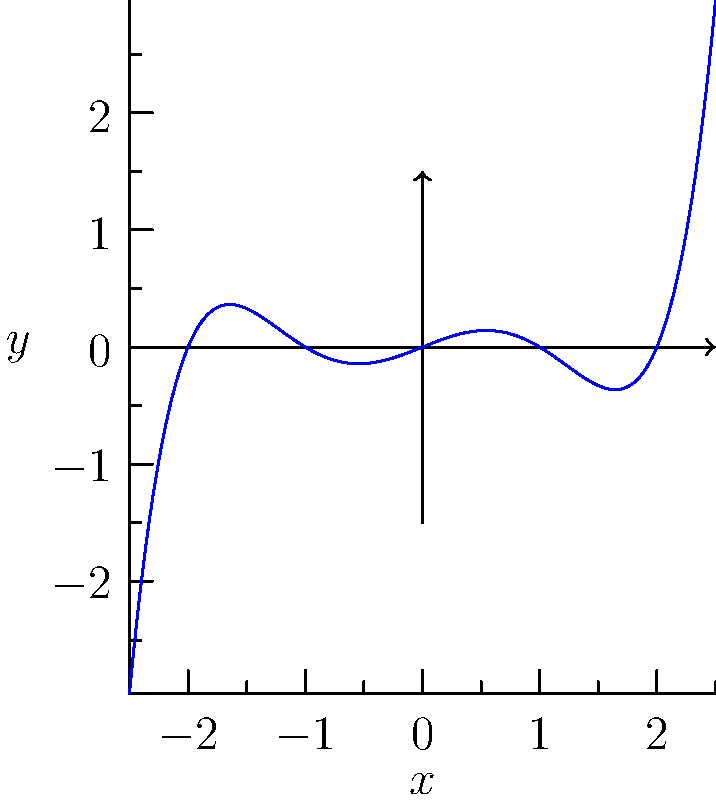As a developer of educational software, you're creating a module on polynomial analysis. Given the graph of the polynomial function $f(x) = ax^5 + bx^3 + cx$ where $a$, $b$, and $c$ are non-zero constants, how many real roots does this polynomial have? To determine the number of real roots, we need to analyze where the graph intersects the x-axis:

1. Real roots occur where $f(x) = 0$, which are the x-intercepts of the graph.

2. Examining the graph:
   - The function starts below the x-axis on the left side.
   - It crosses the x-axis from below, creating the first root.
   - It crosses again from above, giving the second root.
   - It crosses once more from below, providing the third root.
   - The function then continues above the x-axis as x increases.

3. Each crossing of the x-axis represents a real root of the polynomial.

4. We can see that the graph crosses the x-axis exactly three times.

5. Therefore, this polynomial has three real roots.

This visual analysis is crucial for developing intuitive educational software, as it connects the algebraic concept of roots with their graphical representation.
Answer: 3 real roots 